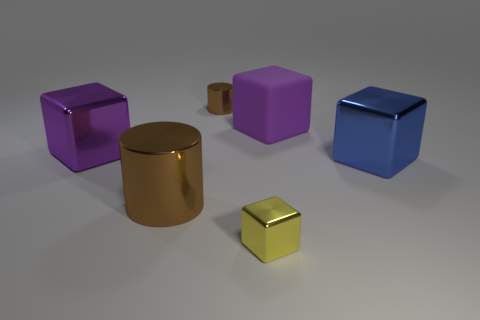Add 1 big blue spheres. How many objects exist? 7 Subtract all gray blocks. Subtract all red cylinders. How many blocks are left? 4 Subtract all blocks. How many objects are left? 2 Add 4 big brown objects. How many big brown objects are left? 5 Add 2 metallic cylinders. How many metallic cylinders exist? 4 Subtract 0 brown balls. How many objects are left? 6 Subtract all large purple cubes. Subtract all big brown cylinders. How many objects are left? 3 